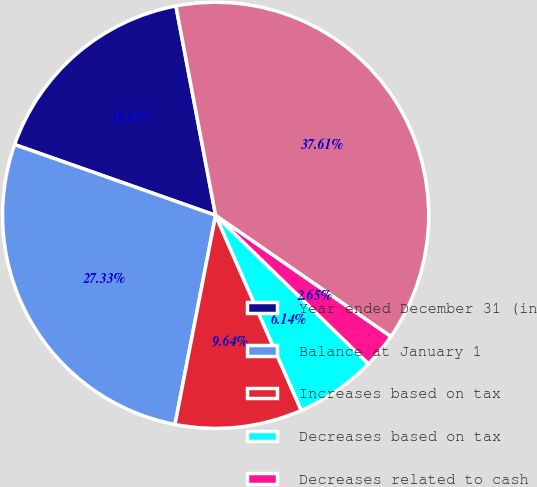Convert chart to OTSL. <chart><loc_0><loc_0><loc_500><loc_500><pie_chart><fcel>Year ended December 31 (in<fcel>Balance at January 1<fcel>Increases based on tax<fcel>Decreases based on tax<fcel>Decreases related to cash<fcel>Balance at December 31<nl><fcel>16.63%<fcel>27.33%<fcel>9.64%<fcel>6.14%<fcel>2.65%<fcel>37.61%<nl></chart> 